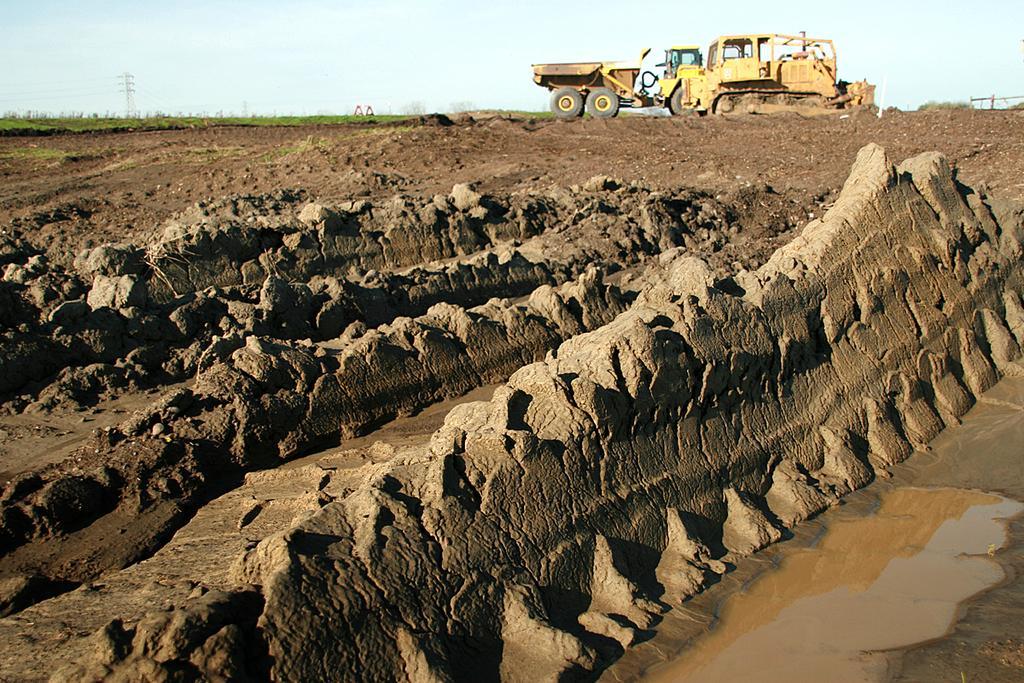Could you give a brief overview of what you see in this image? In the center of the image we can see water and mud. In the background, we can see the sky, grass, one vehicle and a few other objects. 